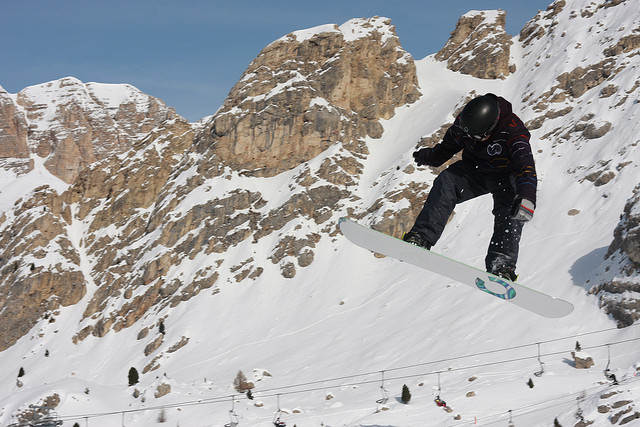Describe the emotions and possible thoughts of the snowboarder during the jump. The snowboarder likely feels a mixture of exhilaration and concentration during the jump. The thrill of being airborne combined with the focus required to execute the trick safely would dominate their thoughts. They might also feel a deep connection with the natural surroundings, experiencing a sense of freedom and adventure. Can you explain how the snowboarder might prepare for such a jump? Preparation for such a jump would involve several steps:
1. **Warm-up:** Engaging in warm-up exercises to loosen muscles and improve flexibility.
2. **Inspection:** Carefully inspecting the jump area to understand the terrain and assess any risks.
3. **Practice:** Practicing smaller jumps and tricks to build confidence and refine technique.
4. **Mental Focus:** Visualizing the jump, planning the takeoff, mid-air posture, and landing.
5. **Equipment Check:** Ensuring the snowboard and bindings are securely fastened and in good condition.
By methodically preparing, the snowboarder can minimize risks and enhance performance. What if the snowboarder encountered an unexpected obstacle mid-jump? Encountering an unexpected obstacle mid-jump would require quick reflexes and presence of mind. The snowboarder might have to adjust their body position to avoid the obstacle, possibly shifting their weight, knees, or arms to alter their trajectory. Remaining calm and relying on their training and experience would be crucial to manage the situation safely. Imagine the snowboarder is embarking on a journey across multiple countries with diverse snowboarding terrains. What could be their itinerary? Embarking on an international snowboarding adventure, the snowboarder might plan an itinerary like this:
1. **Switzerland:** Exploring the pristine slopes of the Swiss Alps, starting with Zermatt and then moving to Verbier for its challenging terrain.
2. **Japan:** Experiencing the powder snow of Hokkaido, particularly at Niseko and Furano resorts.
3. **Canada:** Enjoying the vast, powdery slopes of Whistler Blackcomb and then heading to Banff for its scenic beauty.
4. **New Zealand:** Snowboarding in the southern hemisphere at Queenstown's Remarkables and Wanaka's Treble Cone.
5. **Chile:** Riding the unique terrain of South America's Andes in resorts like Valle Nevado and Portillo.
6. **Austria:** Finishing the trip in the European Alps, exploring the diverse slopes of St. Anton and Kitzbühel.
Such an itinerary would offer a mix of landscapes, snow conditions, and cultural experiences, making for an unforgettable global snowboarding journey. 